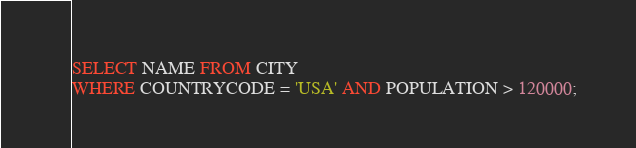<code> <loc_0><loc_0><loc_500><loc_500><_SQL_>SELECT NAME FROM CITY
WHERE COUNTRYCODE = 'USA' AND POPULATION > 120000; 
</code> 